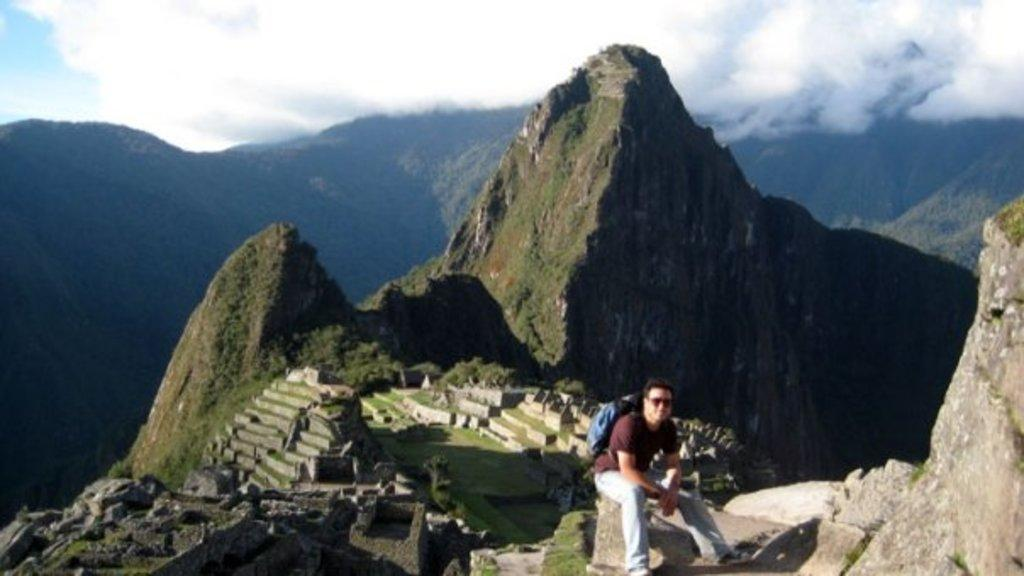Who is present in the image? There is a person in the image. What is the person wearing? The person is wearing a bag. What type of terrain is visible in the image? There are rocks and grass in the image. What can be seen in the background of the image? There are mountains and the sky in the background of the image. What is the condition of the sky in the image? Clouds are present in the sky. What time of day is it in the image, specifically in the afternoon? The time of day is not specified in the image, and there is no indication of the afternoon. 